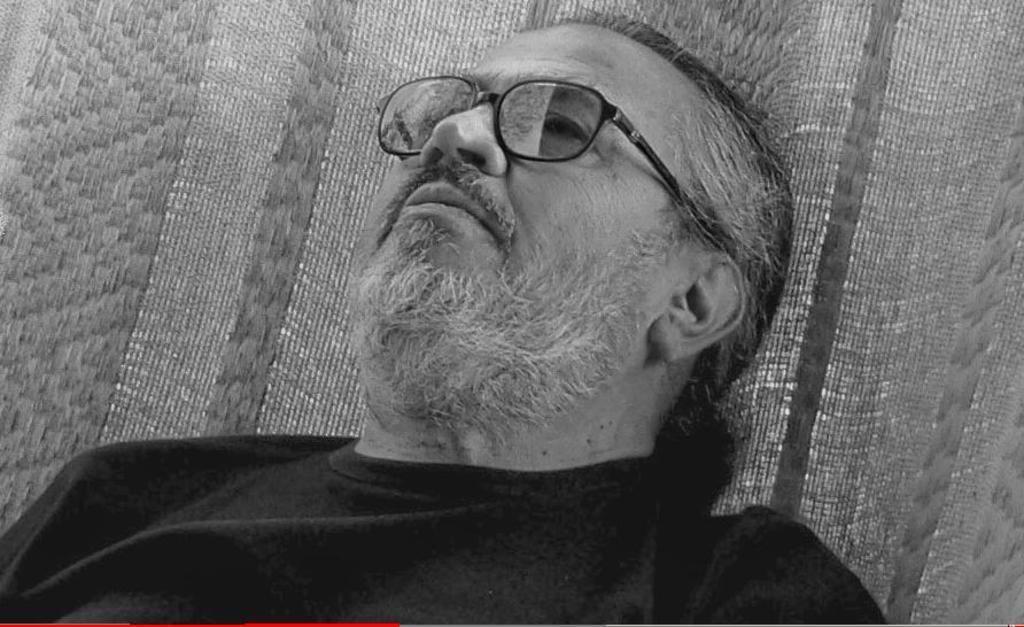Describe this image in one or two sentences. The man in the middle of the picture wearing a black T-shirt is sleeping. Behind him, we see a cloth or a net. This is a black and white picture. 